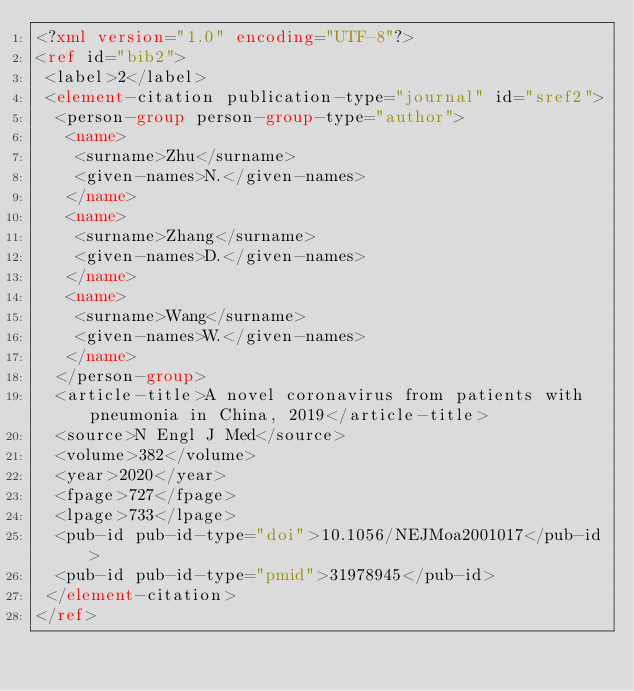<code> <loc_0><loc_0><loc_500><loc_500><_XML_><?xml version="1.0" encoding="UTF-8"?>
<ref id="bib2">
 <label>2</label>
 <element-citation publication-type="journal" id="sref2">
  <person-group person-group-type="author">
   <name>
    <surname>Zhu</surname>
    <given-names>N.</given-names>
   </name>
   <name>
    <surname>Zhang</surname>
    <given-names>D.</given-names>
   </name>
   <name>
    <surname>Wang</surname>
    <given-names>W.</given-names>
   </name>
  </person-group>
  <article-title>A novel coronavirus from patients with pneumonia in China, 2019</article-title>
  <source>N Engl J Med</source>
  <volume>382</volume>
  <year>2020</year>
  <fpage>727</fpage>
  <lpage>733</lpage>
  <pub-id pub-id-type="doi">10.1056/NEJMoa2001017</pub-id>
  <pub-id pub-id-type="pmid">31978945</pub-id>
 </element-citation>
</ref>
</code> 